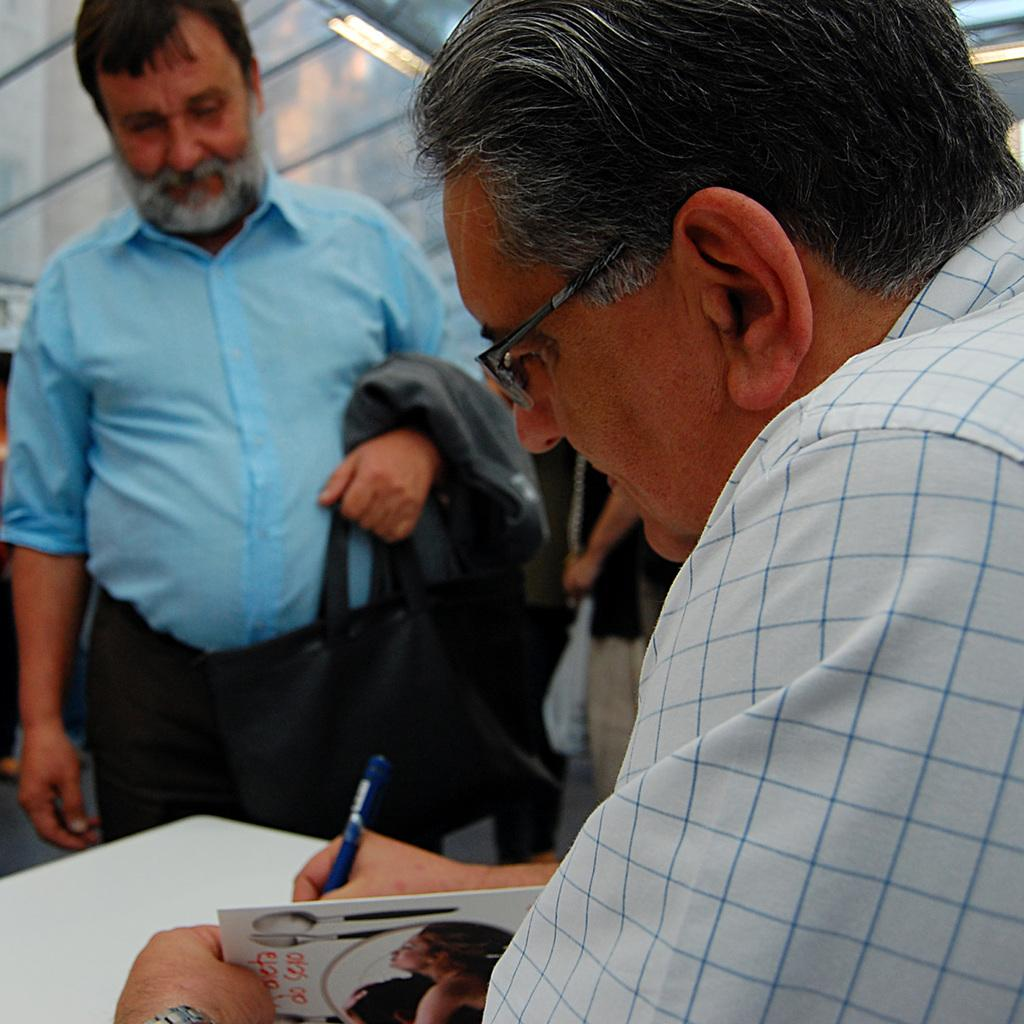How many people are in the image? There are people in the image, but the exact number is not specified. What are some people doing in the image? Some people are holding objects in the image. What can be found at the bottom of the image? There is a white color thing at the bottom of the image. What is located at the top of the image? There is a roof with lights at the top of the image. What type of owl can be seen saying good-bye in the image? There is no owl present in the image, nor is there any indication of someone saying good-bye. 